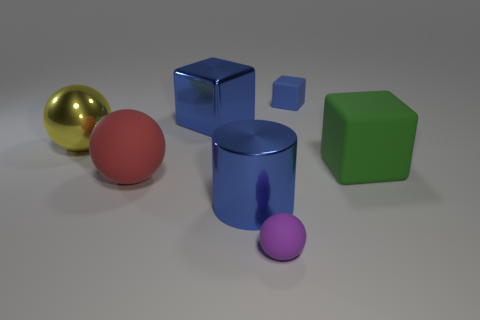Subtract 1 balls. How many balls are left? 2 Add 2 blue matte blocks. How many objects exist? 9 Subtract all cubes. How many objects are left? 4 Add 7 spheres. How many spheres are left? 10 Add 5 large red things. How many large red things exist? 6 Subtract 1 blue cylinders. How many objects are left? 6 Subtract all large rubber things. Subtract all big blocks. How many objects are left? 3 